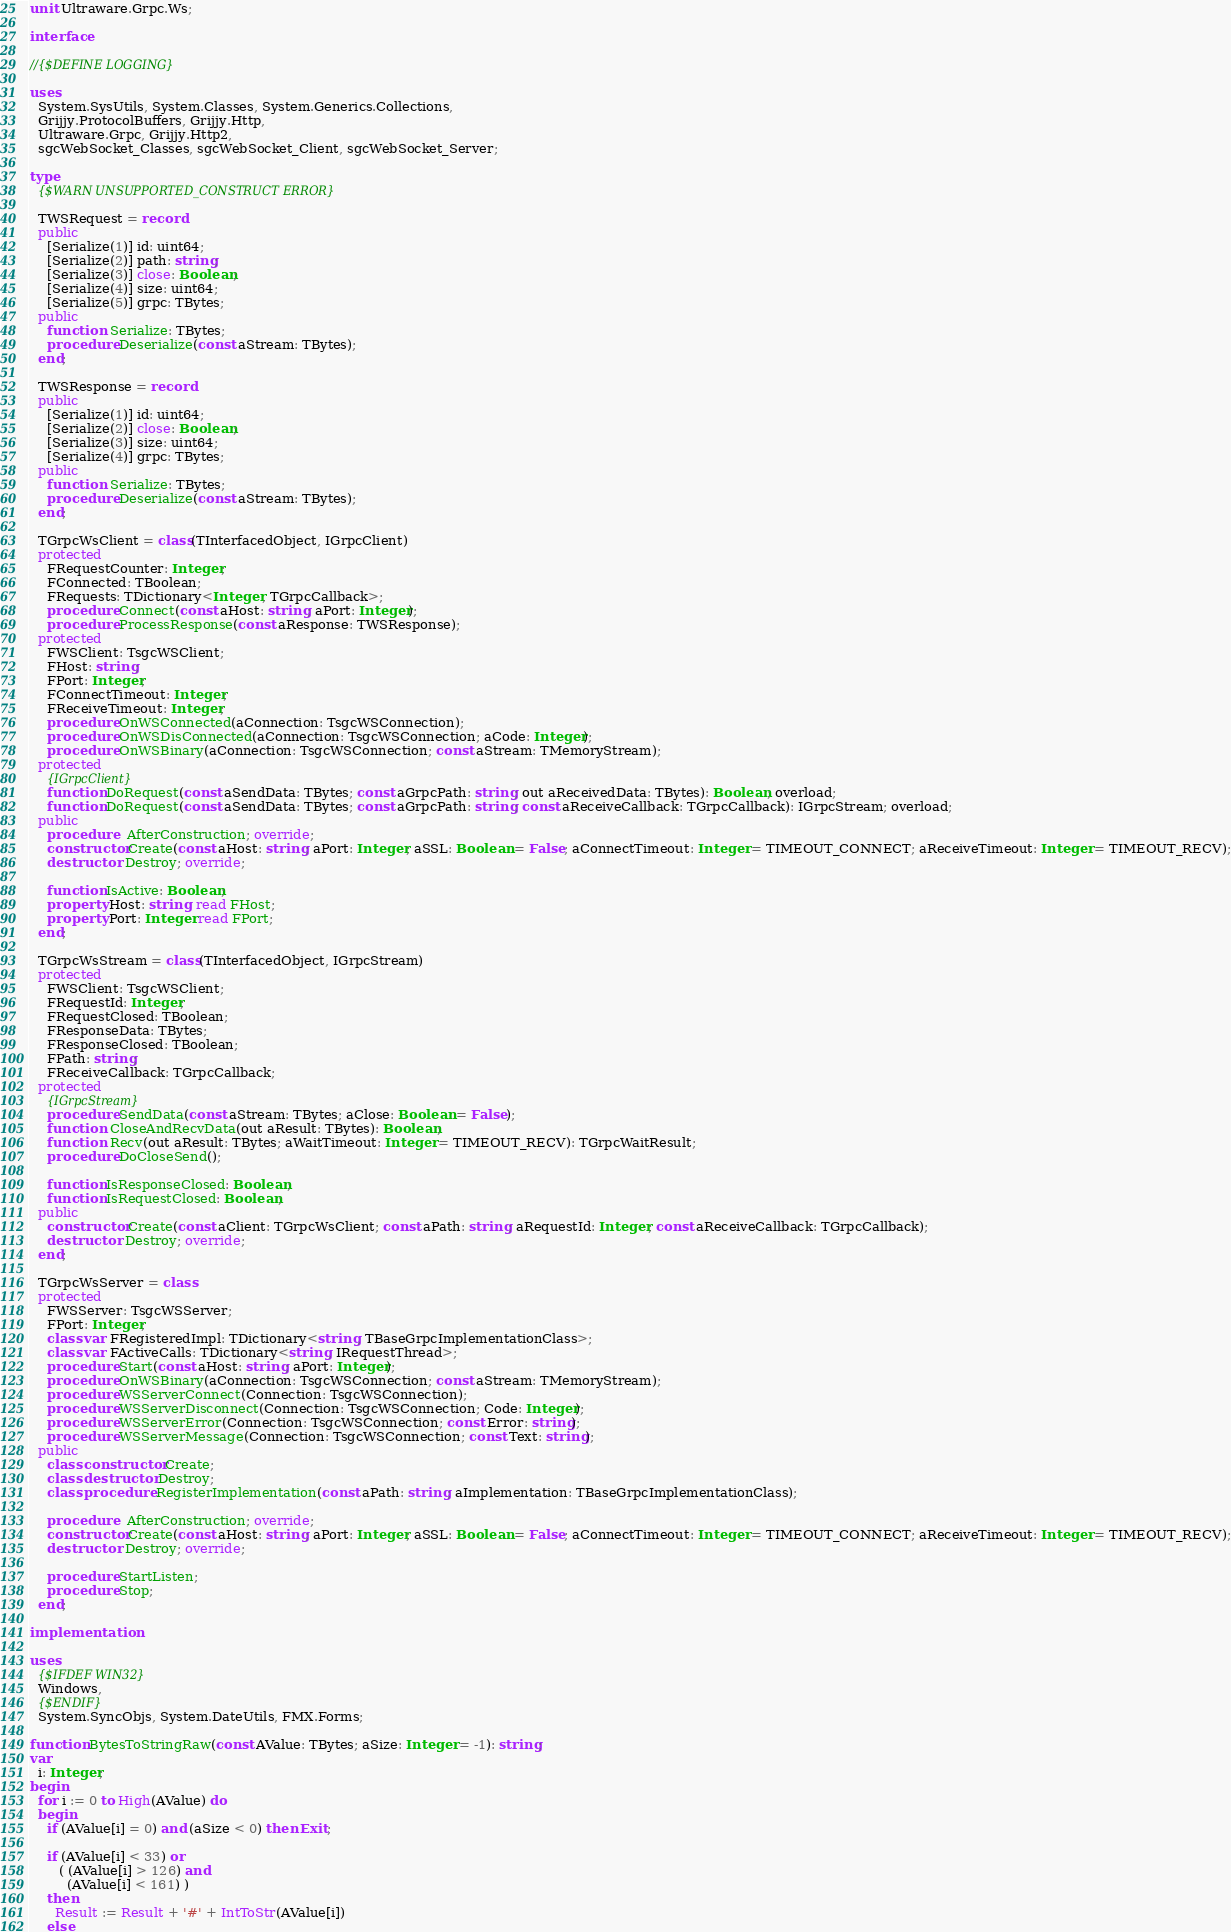<code> <loc_0><loc_0><loc_500><loc_500><_Pascal_>unit Ultraware.Grpc.Ws;

interface

//{$DEFINE LOGGING}

uses
  System.SysUtils, System.Classes, System.Generics.Collections,
  Grijjy.ProtocolBuffers, Grijjy.Http,
  Ultraware.Grpc, Grijjy.Http2,
  sgcWebSocket_Classes, sgcWebSocket_Client, sgcWebSocket_Server;

type
  {$WARN UNSUPPORTED_CONSTRUCT ERROR}

  TWSRequest = record
  public
    [Serialize(1)] id: uint64;
    [Serialize(2)] path: string;
    [Serialize(3)] close: Boolean;
    [Serialize(4)] size: uint64;
    [Serialize(5)] grpc: TBytes;
  public
    function  Serialize: TBytes;
    procedure Deserialize(const aStream: TBytes);
  end;

  TWSResponse = record
  public
    [Serialize(1)] id: uint64;
    [Serialize(2)] close: Boolean;
    [Serialize(3)] size: uint64;
    [Serialize(4)] grpc: TBytes;
  public
    function  Serialize: TBytes;
    procedure Deserialize(const aStream: TBytes);
  end;

  TGrpcWsClient = class(TInterfacedObject, IGrpcClient)
  protected
    FRequestCounter: Integer;
    FConnected: TBoolean;
    FRequests: TDictionary<Integer, TGrpcCallback>;
    procedure Connect(const aHost: string; aPort: Integer);
    procedure ProcessResponse(const aResponse: TWSResponse);
  protected
    FWSClient: TsgcWSClient;
    FHost: string;
    FPort: Integer;
    FConnectTimeout: Integer;
    FReceiveTimeout: Integer;
    procedure OnWSConnected(aConnection: TsgcWSConnection);
    procedure OnWSDisConnected(aConnection: TsgcWSConnection; aCode: Integer);
    procedure OnWSBinary(aConnection: TsgcWSConnection; const aStream: TMemoryStream);
  protected
    {IGrpcClient}
    function DoRequest(const aSendData: TBytes; const aGrpcPath: string; out aReceivedData: TBytes): Boolean; overload;
    function DoRequest(const aSendData: TBytes; const aGrpcPath: string; const aReceiveCallback: TGrpcCallback): IGrpcStream; overload;
  public
    procedure   AfterConstruction; override;
    constructor Create(const aHost: string; aPort: Integer; aSSL: Boolean = False; aConnectTimeout: Integer = TIMEOUT_CONNECT; aReceiveTimeout: Integer = TIMEOUT_RECV);
    destructor  Destroy; override;

    function IsActive: Boolean;
    property Host: string  read FHost;
    property Port: Integer read FPort;
  end;

  TGrpcWsStream = class(TInterfacedObject, IGrpcStream)
  protected
    FWSClient: TsgcWSClient;
    FRequestId: Integer;
    FRequestClosed: TBoolean;
    FResponseData: TBytes;
    FResponseClosed: TBoolean;
    FPath: string;
    FReceiveCallback: TGrpcCallback;
  protected
    {IGrpcStream}
    procedure SendData(const aStream: TBytes; aClose: Boolean = False);
    function  CloseAndRecvData(out aResult: TBytes): Boolean;
    function  Recv(out aResult: TBytes; aWaitTimeout: Integer = TIMEOUT_RECV): TGrpcWaitResult;
    procedure DoCloseSend();

    function IsResponseClosed: Boolean;
    function IsRequestClosed: Boolean;
  public
    constructor Create(const aClient: TGrpcWsClient; const aPath: string; aRequestId: Integer; const aReceiveCallback: TGrpcCallback);
    destructor  Destroy; override;
  end;

  TGrpcWsServer = class
  protected
    FWSServer: TsgcWSServer;
    FPort: Integer;
    class var FRegisteredImpl: TDictionary<string, TBaseGrpcImplementationClass>;
    class var FActiveCalls: TDictionary<string, IRequestThread>;
    procedure Start(const aHost: string; aPort: Integer);
    procedure OnWSBinary(aConnection: TsgcWSConnection; const aStream: TMemoryStream);
    procedure WSServerConnect(Connection: TsgcWSConnection);
    procedure WSServerDisconnect(Connection: TsgcWSConnection; Code: Integer);
    procedure WSServerError(Connection: TsgcWSConnection; const Error: string);
    procedure WSServerMessage(Connection: TsgcWSConnection; const Text: string);
  public
    class constructor Create;
    class destructor Destroy;
    class procedure RegisterImplementation(const aPath: string; aImplementation: TBaseGrpcImplementationClass);

    procedure   AfterConstruction; override;
    constructor Create(const aHost: string; aPort: Integer; aSSL: Boolean = False; aConnectTimeout: Integer = TIMEOUT_CONNECT; aReceiveTimeout: Integer = TIMEOUT_RECV);
    destructor  Destroy; override;

    procedure StartListen;
    procedure Stop;
  end;

implementation

uses
  {$IFDEF WIN32}
  Windows,
  {$ENDIF}
  System.SyncObjs, System.DateUtils, FMX.Forms;

function BytesToStringRaw(const AValue: TBytes; aSize: Integer = -1): string;
var
  i: Integer;
begin
  for i := 0 to High(AValue) do
  begin
    if (AValue[i] = 0) and (aSize < 0) then Exit;

    if (AValue[i] < 33) or
       ( (AValue[i] > 126) and
         (AValue[i] < 161) )
    then
      Result := Result + '#' + IntToStr(AValue[i])
    else</code> 